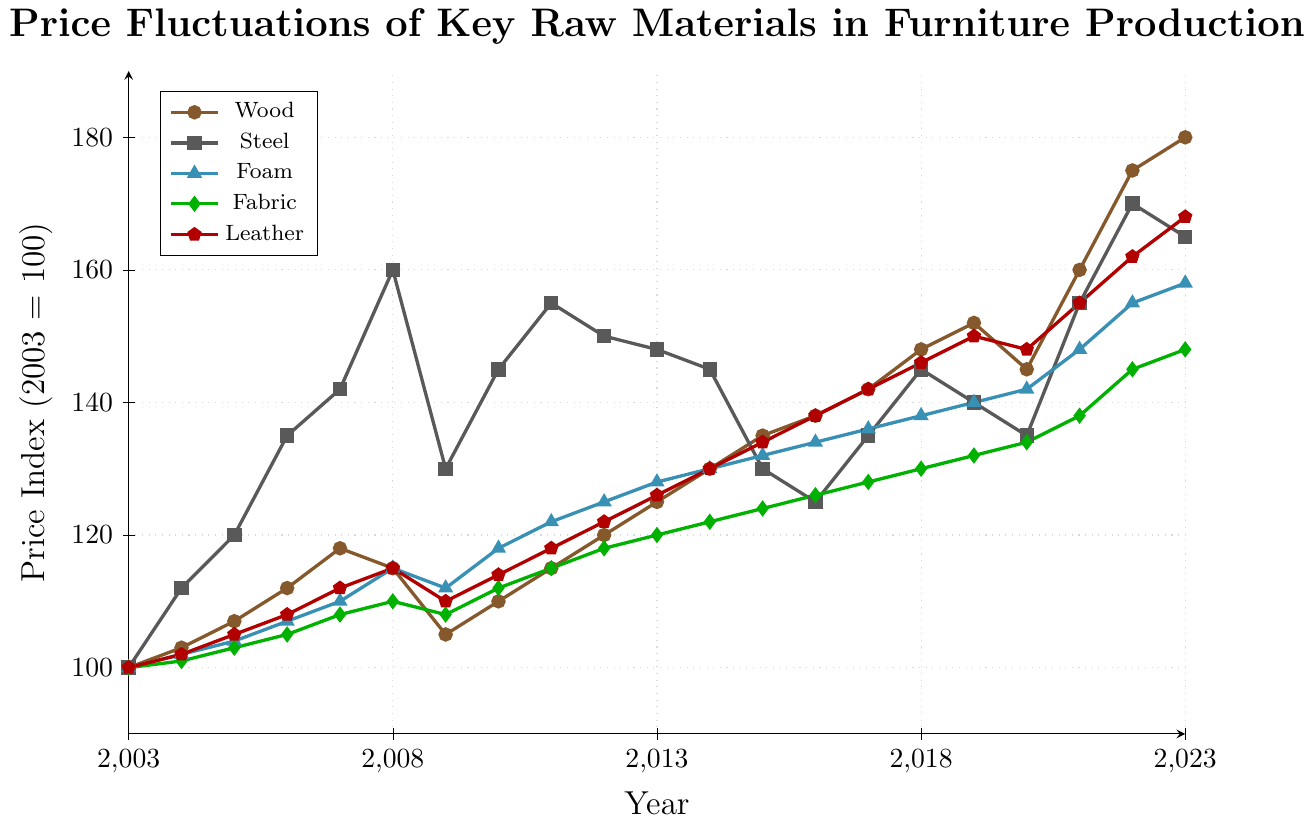1. Which material experienced the highest price increase from 2003 to 2023? To find the material with the highest price increase, subtract the price index of 2003 from the price index of 2023 for each material. Wood increased from 100 to 180 (80 points), Steel from 100 to 165 (65 points), Foam from 100 to 158 (58 points), Fabric from 100 to 148 (48 points), and Leather from 100 to 168 (68 points). Wood had the highest increase of 80 points.
Answer: Wood 2. Between 2015 and 2023, which two materials have the closest final price index? Look at the price indices of 2015 and 2023 for each material, and compare their differences. In 2023, Wood is 180, Steel is 165, Foam is 158, Fabric is 148, and Leather is 168. Leather and Steel have the closest indices, both being within 3 points of each other (165 and 168).
Answer: Steel and Leather 3. Did any material's price index decrease between any two consecutive years? If so, which ones? Look through the graph for any downward slopes between consecutive years. For Wood, between 2007 and 2008; for Steel, between 2008 and 2009, 2011 and 2012, and 2017 and 2018; for Foam, between 2018 and 2019; for Fabric, between 2020 and 2021; for Leather, between 2018 and 2019. Hence, Steel, Foam, and Leather had price index decreases between some consecutive years.
Answer: Steel, Foam, and Leather 4. Which material had the most consistent price increase over 20 years? By observing the trend lines, Foam appears to have the most consistent increases without significant drops or sharp rises. The increases in the Foam line each year remain relatively steady compared to others.
Answer: Foam 5. In 2009, which material had the highest price index and what was its value? Refer to the data point for the year 2009 for all materials. Steel had the highest price index at that year, which was 130.
Answer: Steel at 130 6. By how much has the price index of Fabric increased from 2019 to 2023? Subtract Fabric's price index in 2019 from its index in 2023. Fabric in 2019 was at 132, and in 2023 it is at 148. The difference is 148 - 132 = 16.
Answer: 16 7. Calculate the average price index of Wood over the first ten years. Add the price indices of Wood for the first ten years (2003 to 2012) and divide by 10. (100 + 103 + 107 + 112 + 118 + 115 + 105 + 110 + 115 + 120) / 10 = 1105 / 10 = 110.5
Answer: 110.5 8. Which year saw the highest increase in the price index of Steel compared to the previous year? By examining the changes year over year, the largest increase occurred between 2007 and 2008, where Steel increased from 142 to 160, a difference of 18 points.
Answer: 2008 9. Is there a year where all the materials show an increase in their price index over the previous year? Inspect the graph for any year where all materials show an upward trend from the previous year. In 2021, all materials (Wood, Steel, Foam, Fabric, Leather) show increased values compared to 2020.
Answer: 2021 